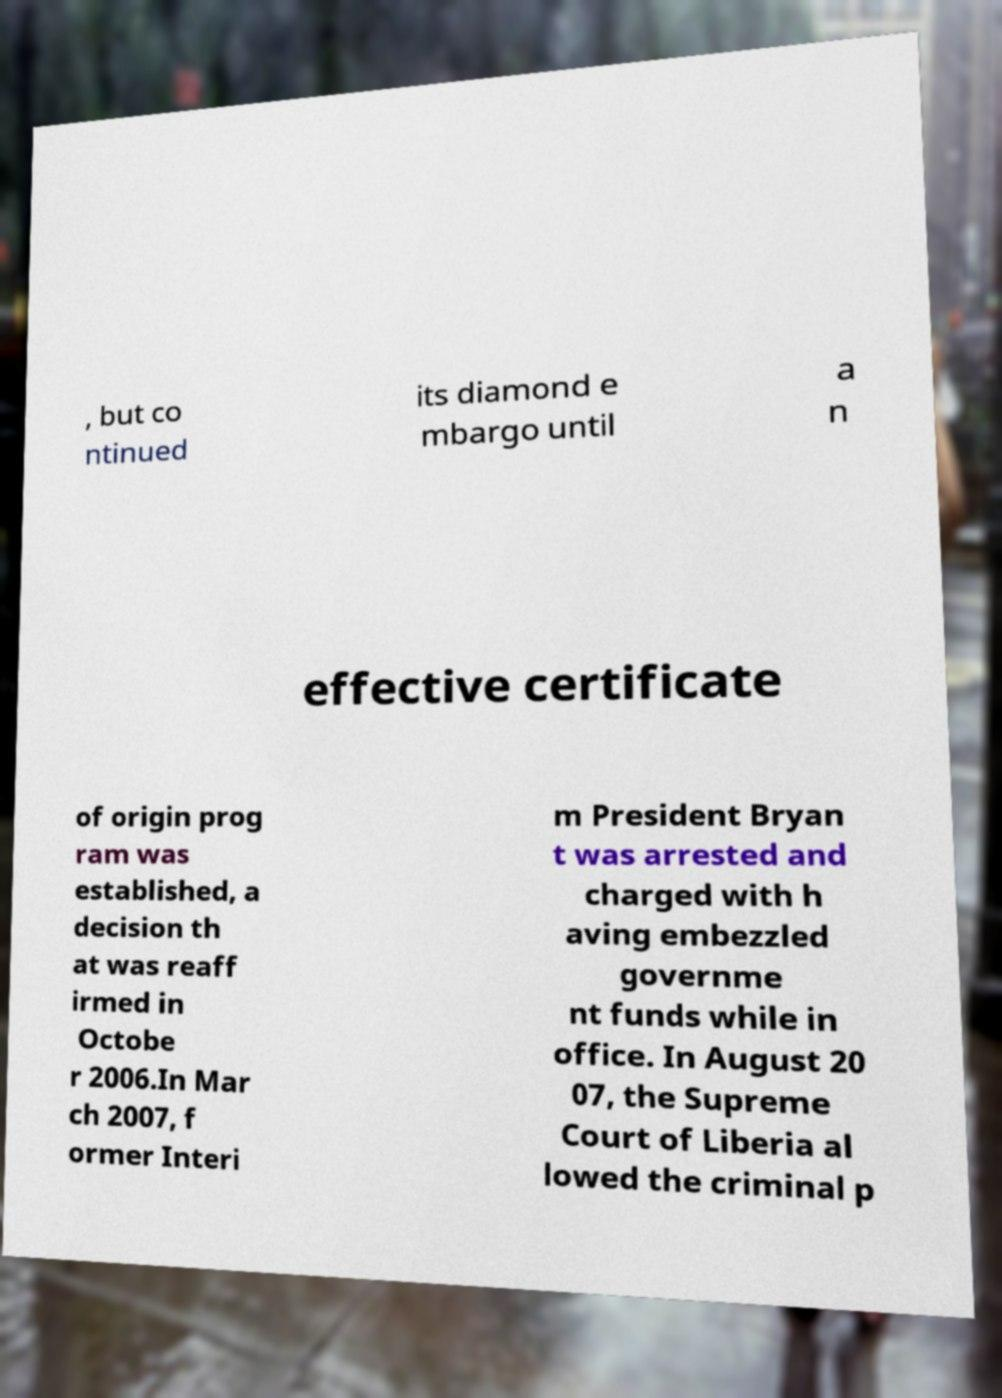Can you accurately transcribe the text from the provided image for me? , but co ntinued its diamond e mbargo until a n effective certificate of origin prog ram was established, a decision th at was reaff irmed in Octobe r 2006.In Mar ch 2007, f ormer Interi m President Bryan t was arrested and charged with h aving embezzled governme nt funds while in office. In August 20 07, the Supreme Court of Liberia al lowed the criminal p 